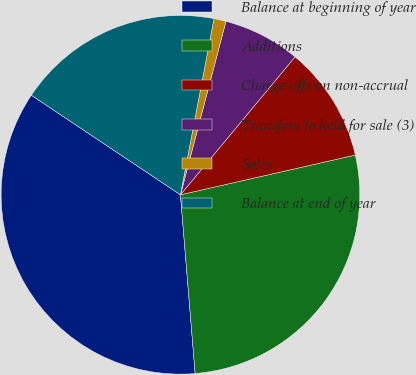Convert chart to OTSL. <chart><loc_0><loc_0><loc_500><loc_500><pie_chart><fcel>Balance at beginning of year<fcel>Additions<fcel>Charge-offs on non-accrual<fcel>Transfers to held for sale (3)<fcel>Sales<fcel>Balance at end of year<nl><fcel>35.68%<fcel>27.25%<fcel>10.41%<fcel>6.95%<fcel>1.09%<fcel>18.62%<nl></chart> 